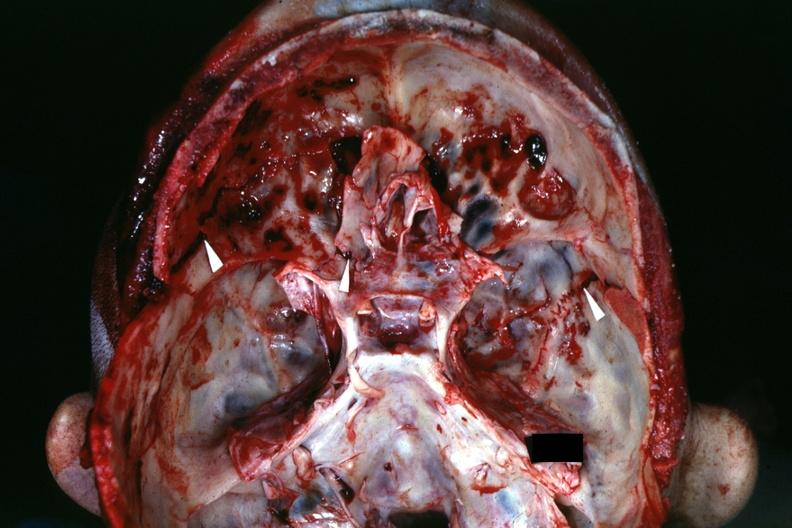how does this image show view of base of skull?
Answer the question using a single word or phrase. With several well shown fractures 